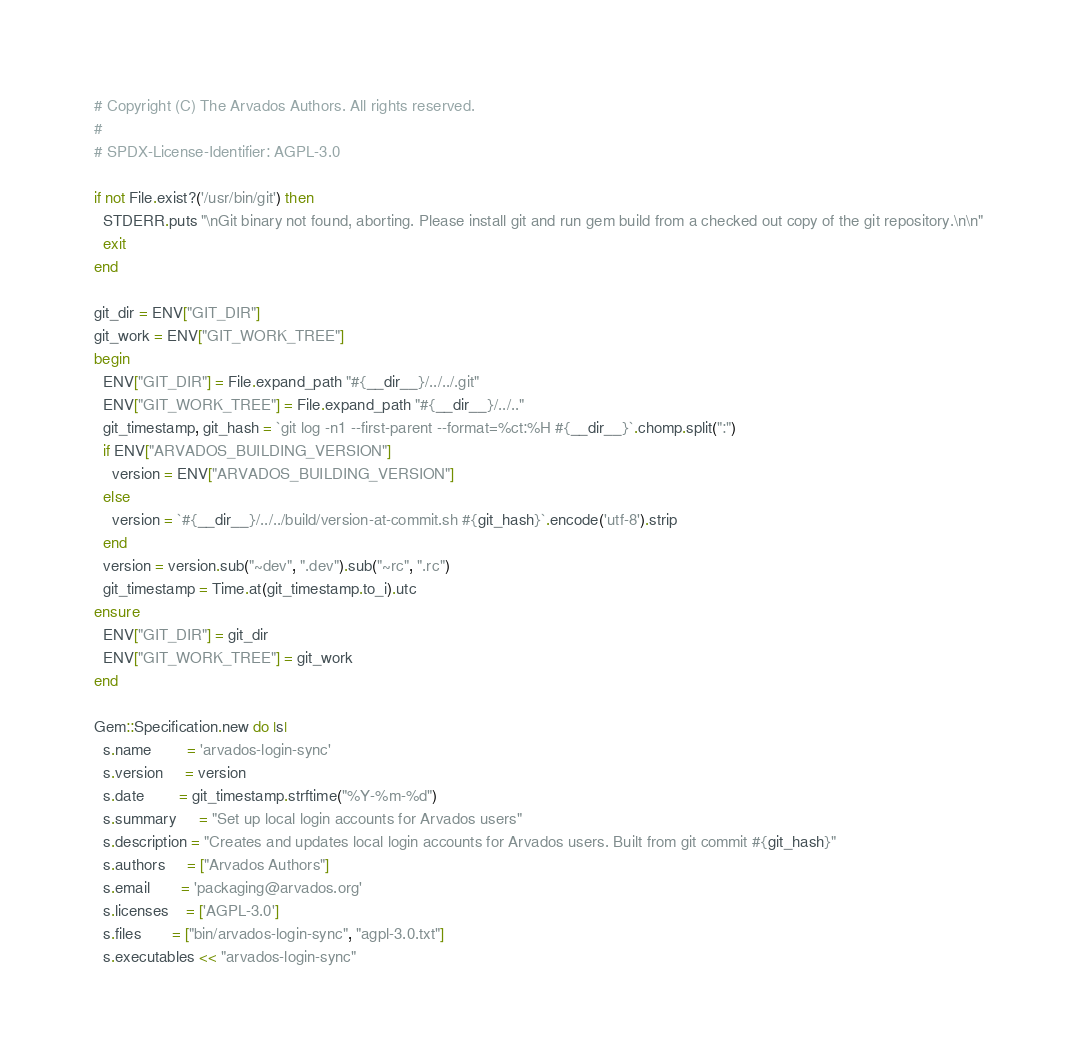<code> <loc_0><loc_0><loc_500><loc_500><_Ruby_># Copyright (C) The Arvados Authors. All rights reserved.
#
# SPDX-License-Identifier: AGPL-3.0

if not File.exist?('/usr/bin/git') then
  STDERR.puts "\nGit binary not found, aborting. Please install git and run gem build from a checked out copy of the git repository.\n\n"
  exit
end

git_dir = ENV["GIT_DIR"]
git_work = ENV["GIT_WORK_TREE"]
begin
  ENV["GIT_DIR"] = File.expand_path "#{__dir__}/../../.git"
  ENV["GIT_WORK_TREE"] = File.expand_path "#{__dir__}/../.."
  git_timestamp, git_hash = `git log -n1 --first-parent --format=%ct:%H #{__dir__}`.chomp.split(":")
  if ENV["ARVADOS_BUILDING_VERSION"]
    version = ENV["ARVADOS_BUILDING_VERSION"]
  else
    version = `#{__dir__}/../../build/version-at-commit.sh #{git_hash}`.encode('utf-8').strip
  end
  version = version.sub("~dev", ".dev").sub("~rc", ".rc")
  git_timestamp = Time.at(git_timestamp.to_i).utc
ensure
  ENV["GIT_DIR"] = git_dir
  ENV["GIT_WORK_TREE"] = git_work
end

Gem::Specification.new do |s|
  s.name        = 'arvados-login-sync'
  s.version     = version
  s.date        = git_timestamp.strftime("%Y-%m-%d")
  s.summary     = "Set up local login accounts for Arvados users"
  s.description = "Creates and updates local login accounts for Arvados users. Built from git commit #{git_hash}"
  s.authors     = ["Arvados Authors"]
  s.email       = 'packaging@arvados.org'
  s.licenses    = ['AGPL-3.0']
  s.files       = ["bin/arvados-login-sync", "agpl-3.0.txt"]
  s.executables << "arvados-login-sync"</code> 